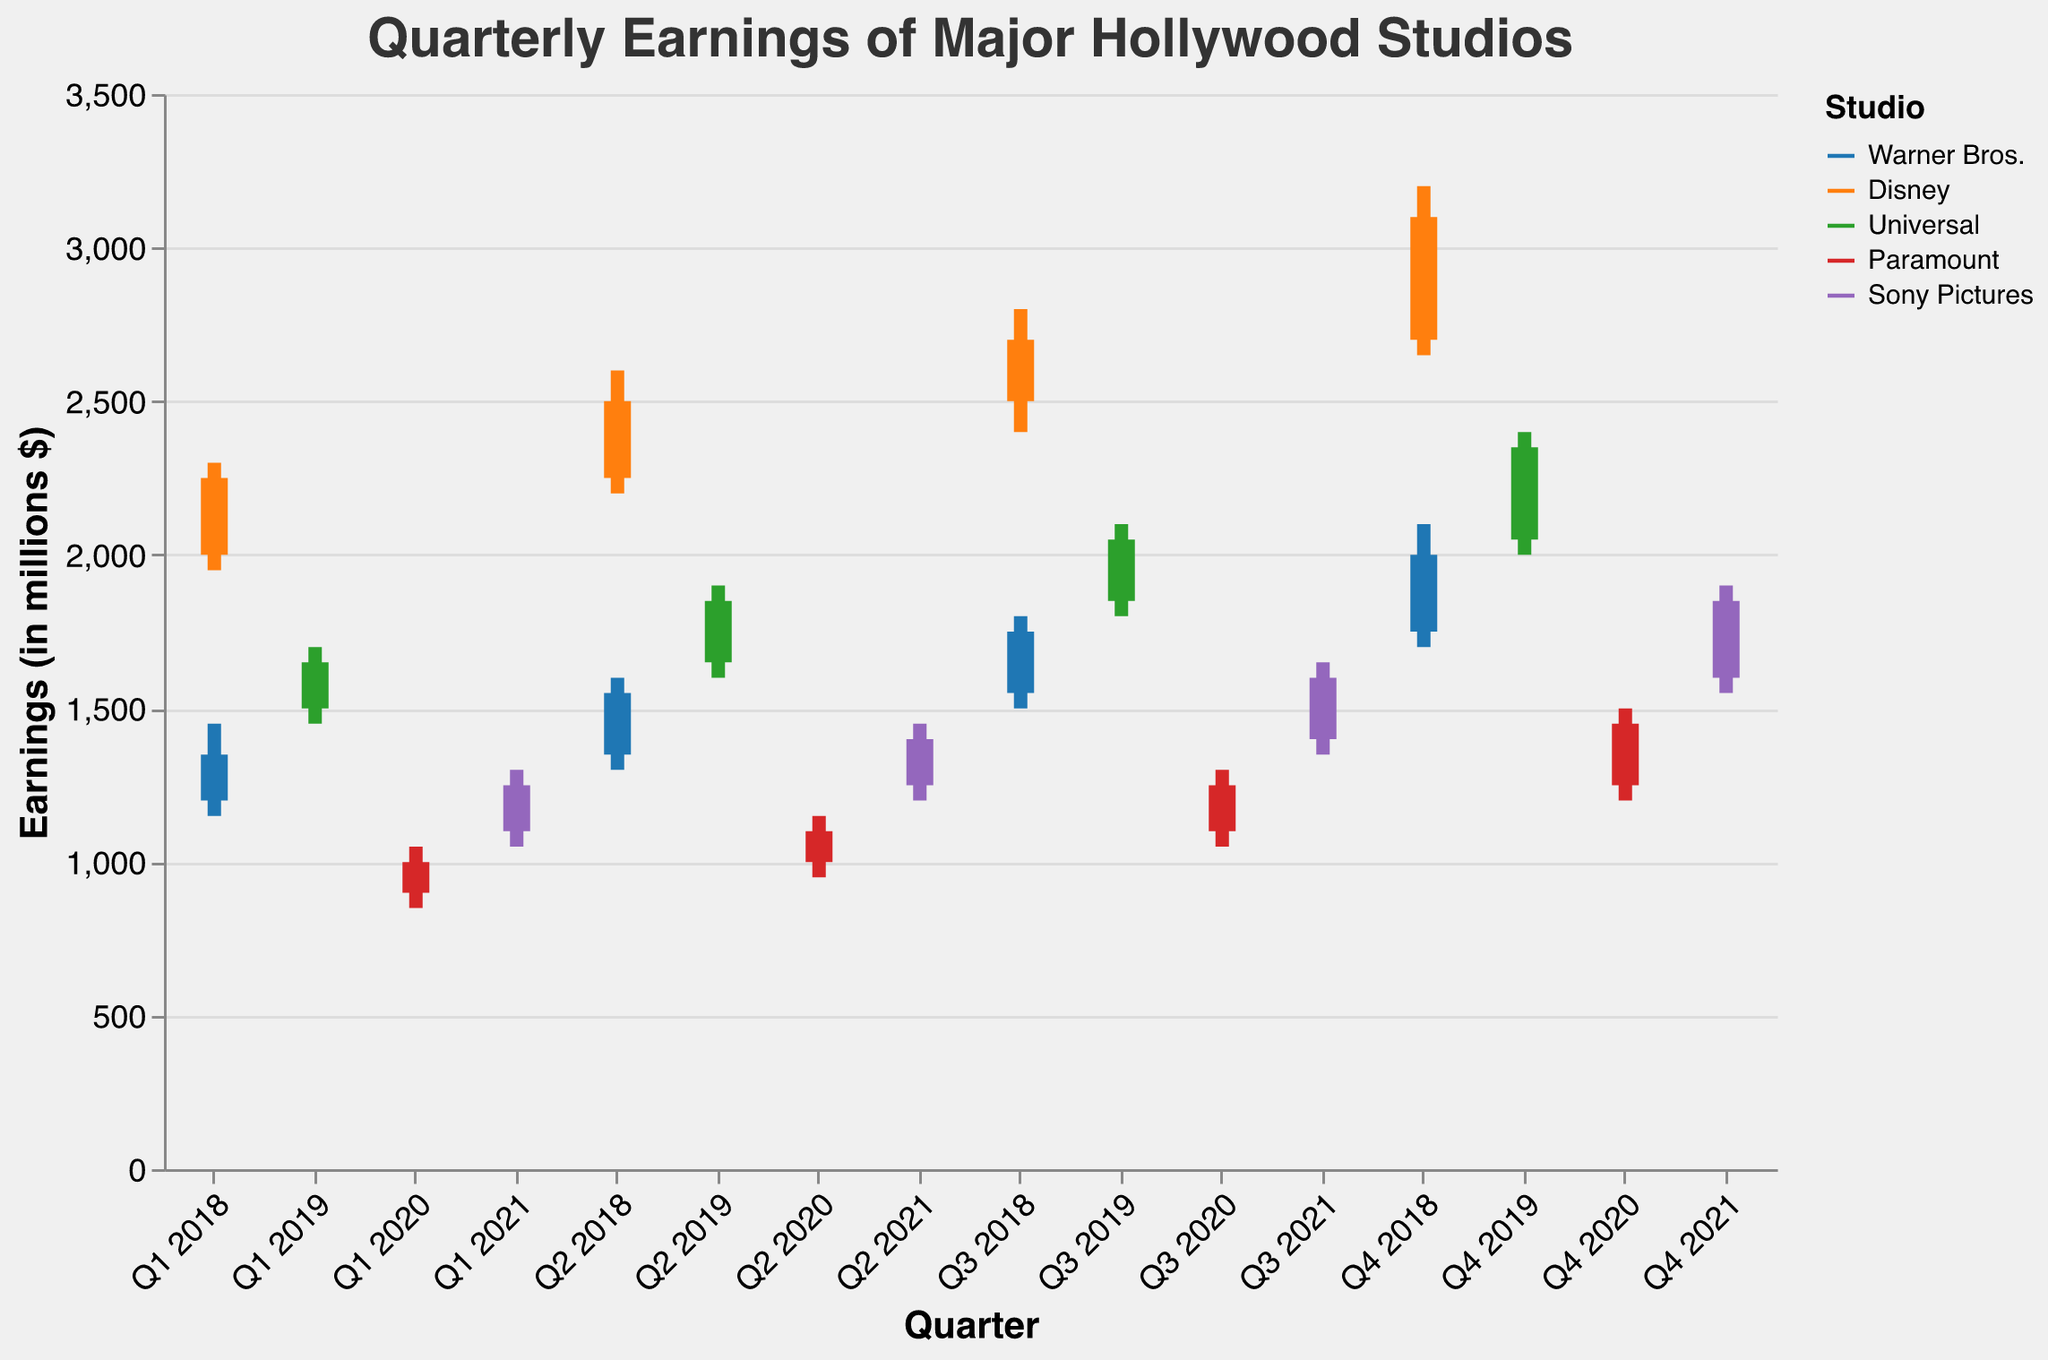What are the earnings ranges (low to high) for Warner Bros. in Q3 2018? In Q3 2018, Warner Bros. has a low of 1500 and a high of 1800.
Answer: 1500 to 1800 Which studio had the highest earnings in Q4 2018? By examining the high values in Q4 2018, Disney had the highest earnings with a high value of 3200.
Answer: Disney How did Disney's earnings change from Q1 2018 to Q4 2018? Disney's opened at 2000 and closed at 3100 in Q4 2018, showing a consistent increase each quarter.
Answer: Increased What was the closing value for Universal in Q2 2019? The closing value for Universal in Q2 2019 is shown as 1850 in the chart.
Answer: 1850 Compare the quarterly closing values of Sony Pictures in 2021. Which quarter had the highest close? Sony Pictures closed at 1250 in Q1, 1400 in Q2, 1600 in Q3, and 1850 in Q4 2021. The highest closing value is in Q4 2021.
Answer: Q4 2021 Which studio had the lowest opening earnings in Q1 of their respective years? By comparing the Q1 opening values: Warner Bros. (1200), Disney (2000), Universal (1500), Paramount (900), Sony Pictures (1100), Paramount had the lowest opening.
Answer: Paramount What was the average closing value for Warner Bros. over 2018? Warner Bros. closed at 1350 (Q1), 1550 (Q2), 1750 (Q3), 2000 (Q4) in 2018. The average is (1350+1550+1750+2000)/4 = 1662.5.
Answer: 1662.5 Did any studio see a decrease in earnings at any point in these periods? If so, which one and when? Checking the figures, no studio showed both high and low values that decrease consistently across quarters within the periods depicted. Each studio's earnings either remained stable or increased.
Answer: No decrease Compare the highest values of Paramount for Q2 and Q3 in 2020. What is the difference? Paramount's high values in Q2 and Q3 2020 are 1150 and 1300 respectively. The difference is 1300 - 1150 = 150.
Answer: 150 Which year's first quarter had the highest opening earnings among all studios? Comparing the Q1 opening values: Warner Bros. (1200 in 2018), Disney (2000 in 2018), Universal (1500 in 2019), Paramount (900 in 2020), Sony Pictures (1100 in 2021), Disney in 2018 had the highest opening.
Answer: Disney 